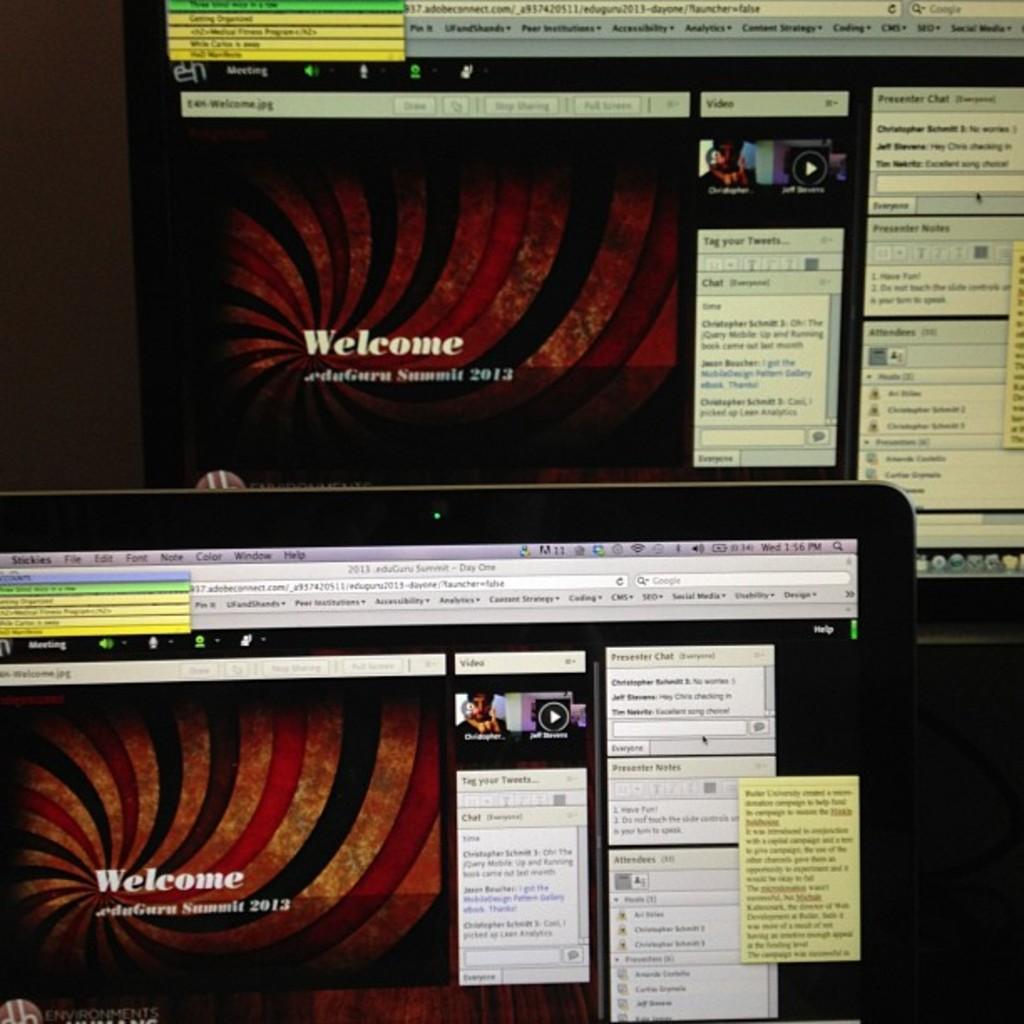What greeting is written on the computer?
Your answer should be very brief. Welcome. 